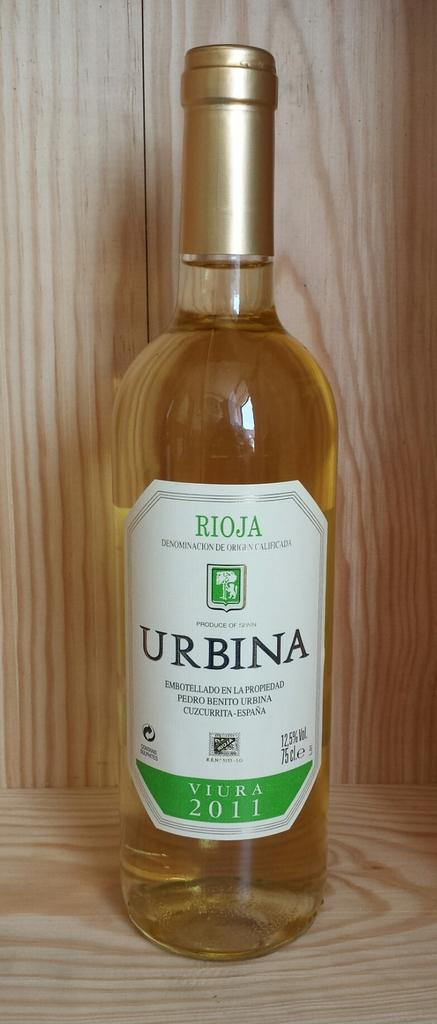<image>
Provide a brief description of the given image. a bottle of rioja urbina viura 2011 with a white and green label 